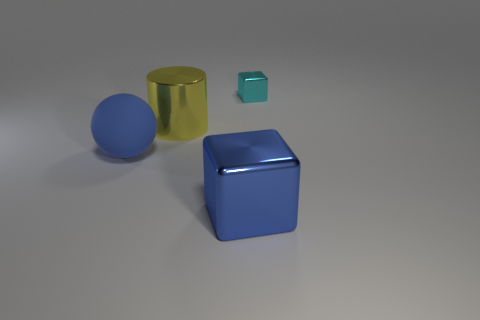Add 3 tiny blue balls. How many objects exist? 7 Add 1 cyan metal things. How many cyan metal things exist? 2 Subtract 0 cyan cylinders. How many objects are left? 4 Subtract all brown metallic balls. Subtract all blue rubber spheres. How many objects are left? 3 Add 2 tiny cyan cubes. How many tiny cyan cubes are left? 3 